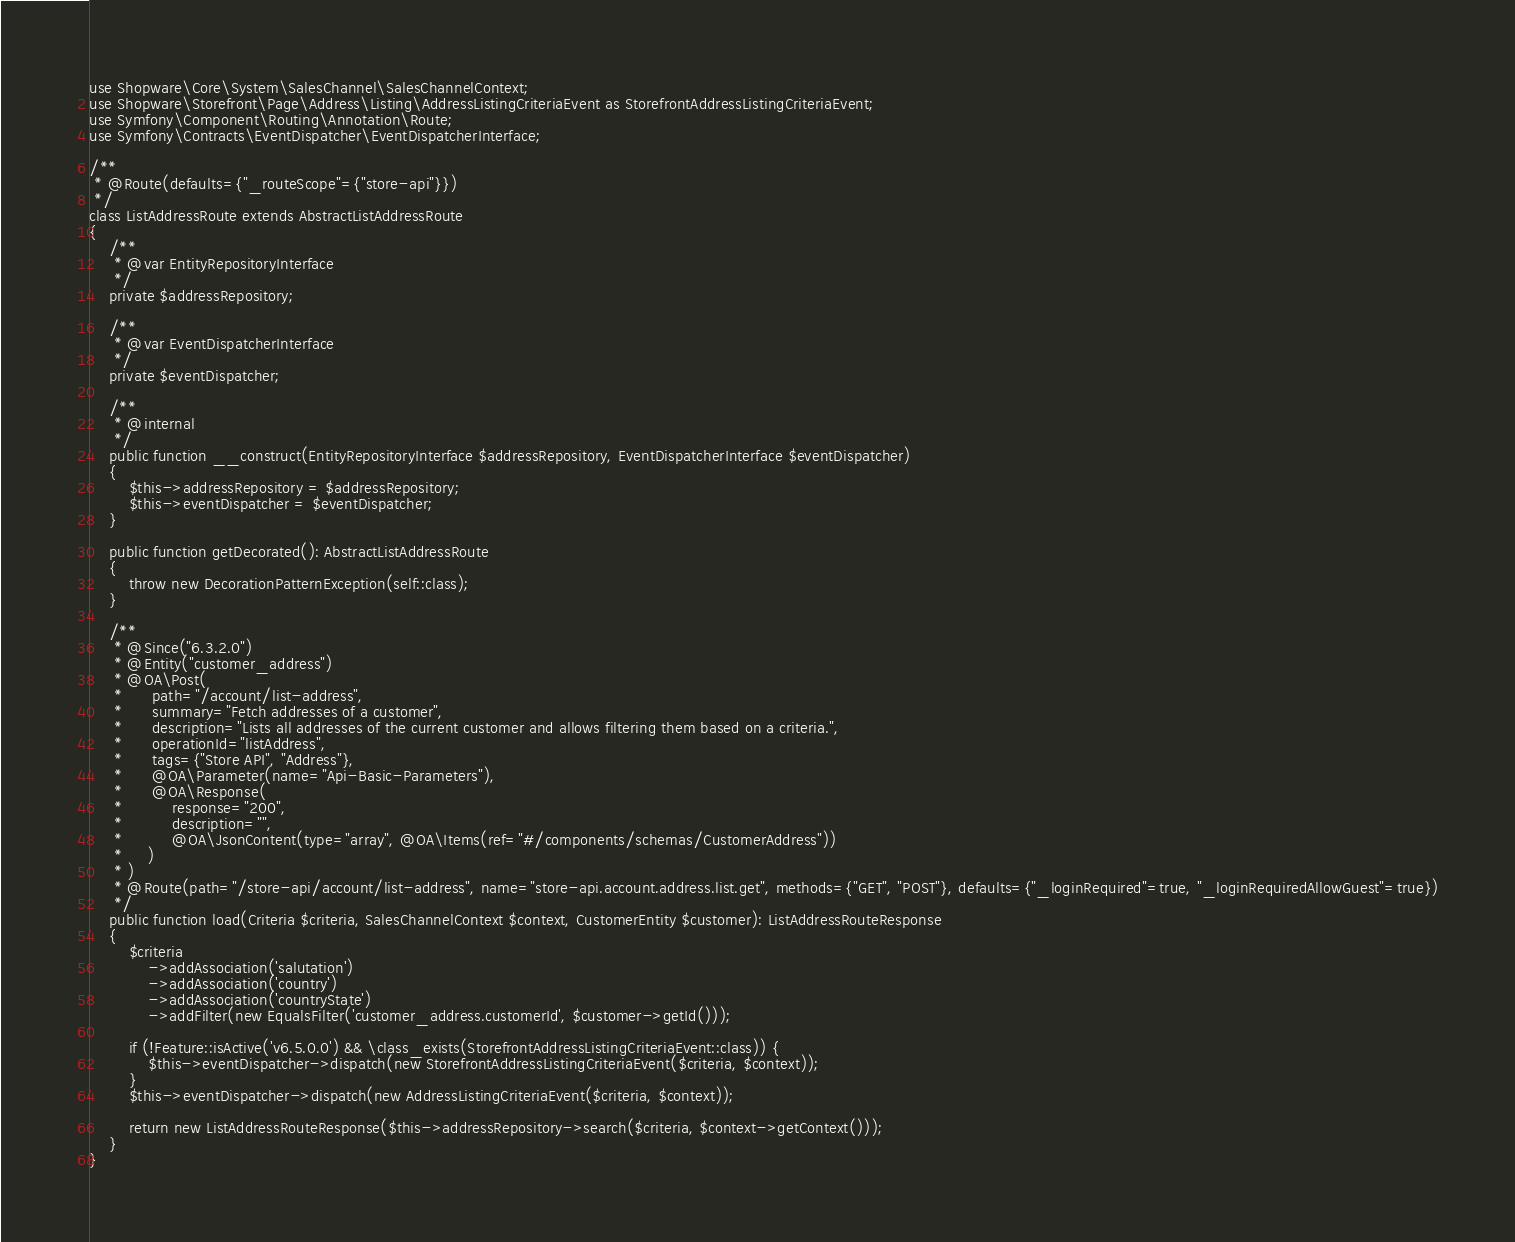<code> <loc_0><loc_0><loc_500><loc_500><_PHP_>use Shopware\Core\System\SalesChannel\SalesChannelContext;
use Shopware\Storefront\Page\Address\Listing\AddressListingCriteriaEvent as StorefrontAddressListingCriteriaEvent;
use Symfony\Component\Routing\Annotation\Route;
use Symfony\Contracts\EventDispatcher\EventDispatcherInterface;

/**
 * @Route(defaults={"_routeScope"={"store-api"}})
 */
class ListAddressRoute extends AbstractListAddressRoute
{
    /**
     * @var EntityRepositoryInterface
     */
    private $addressRepository;

    /**
     * @var EventDispatcherInterface
     */
    private $eventDispatcher;

    /**
     * @internal
     */
    public function __construct(EntityRepositoryInterface $addressRepository, EventDispatcherInterface $eventDispatcher)
    {
        $this->addressRepository = $addressRepository;
        $this->eventDispatcher = $eventDispatcher;
    }

    public function getDecorated(): AbstractListAddressRoute
    {
        throw new DecorationPatternException(self::class);
    }

    /**
     * @Since("6.3.2.0")
     * @Entity("customer_address")
     * @OA\Post(
     *      path="/account/list-address",
     *      summary="Fetch addresses of a customer",
     *      description="Lists all addresses of the current customer and allows filtering them based on a criteria.",
     *      operationId="listAddress",
     *      tags={"Store API", "Address"},
     *      @OA\Parameter(name="Api-Basic-Parameters"),
     *      @OA\Response(
     *          response="200",
     *          description="",
     *          @OA\JsonContent(type="array", @OA\Items(ref="#/components/schemas/CustomerAddress"))
     *     )
     * )
     * @Route(path="/store-api/account/list-address", name="store-api.account.address.list.get", methods={"GET", "POST"}, defaults={"_loginRequired"=true, "_loginRequiredAllowGuest"=true})
     */
    public function load(Criteria $criteria, SalesChannelContext $context, CustomerEntity $customer): ListAddressRouteResponse
    {
        $criteria
            ->addAssociation('salutation')
            ->addAssociation('country')
            ->addAssociation('countryState')
            ->addFilter(new EqualsFilter('customer_address.customerId', $customer->getId()));

        if (!Feature::isActive('v6.5.0.0') && \class_exists(StorefrontAddressListingCriteriaEvent::class)) {
            $this->eventDispatcher->dispatch(new StorefrontAddressListingCriteriaEvent($criteria, $context));
        }
        $this->eventDispatcher->dispatch(new AddressListingCriteriaEvent($criteria, $context));

        return new ListAddressRouteResponse($this->addressRepository->search($criteria, $context->getContext()));
    }
}
</code> 